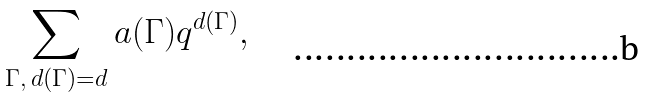Convert formula to latex. <formula><loc_0><loc_0><loc_500><loc_500>\sum _ { { \Gamma } , \, { d ( \Gamma ) = d } } a ( \Gamma ) q ^ { d ( \Gamma ) } ,</formula> 